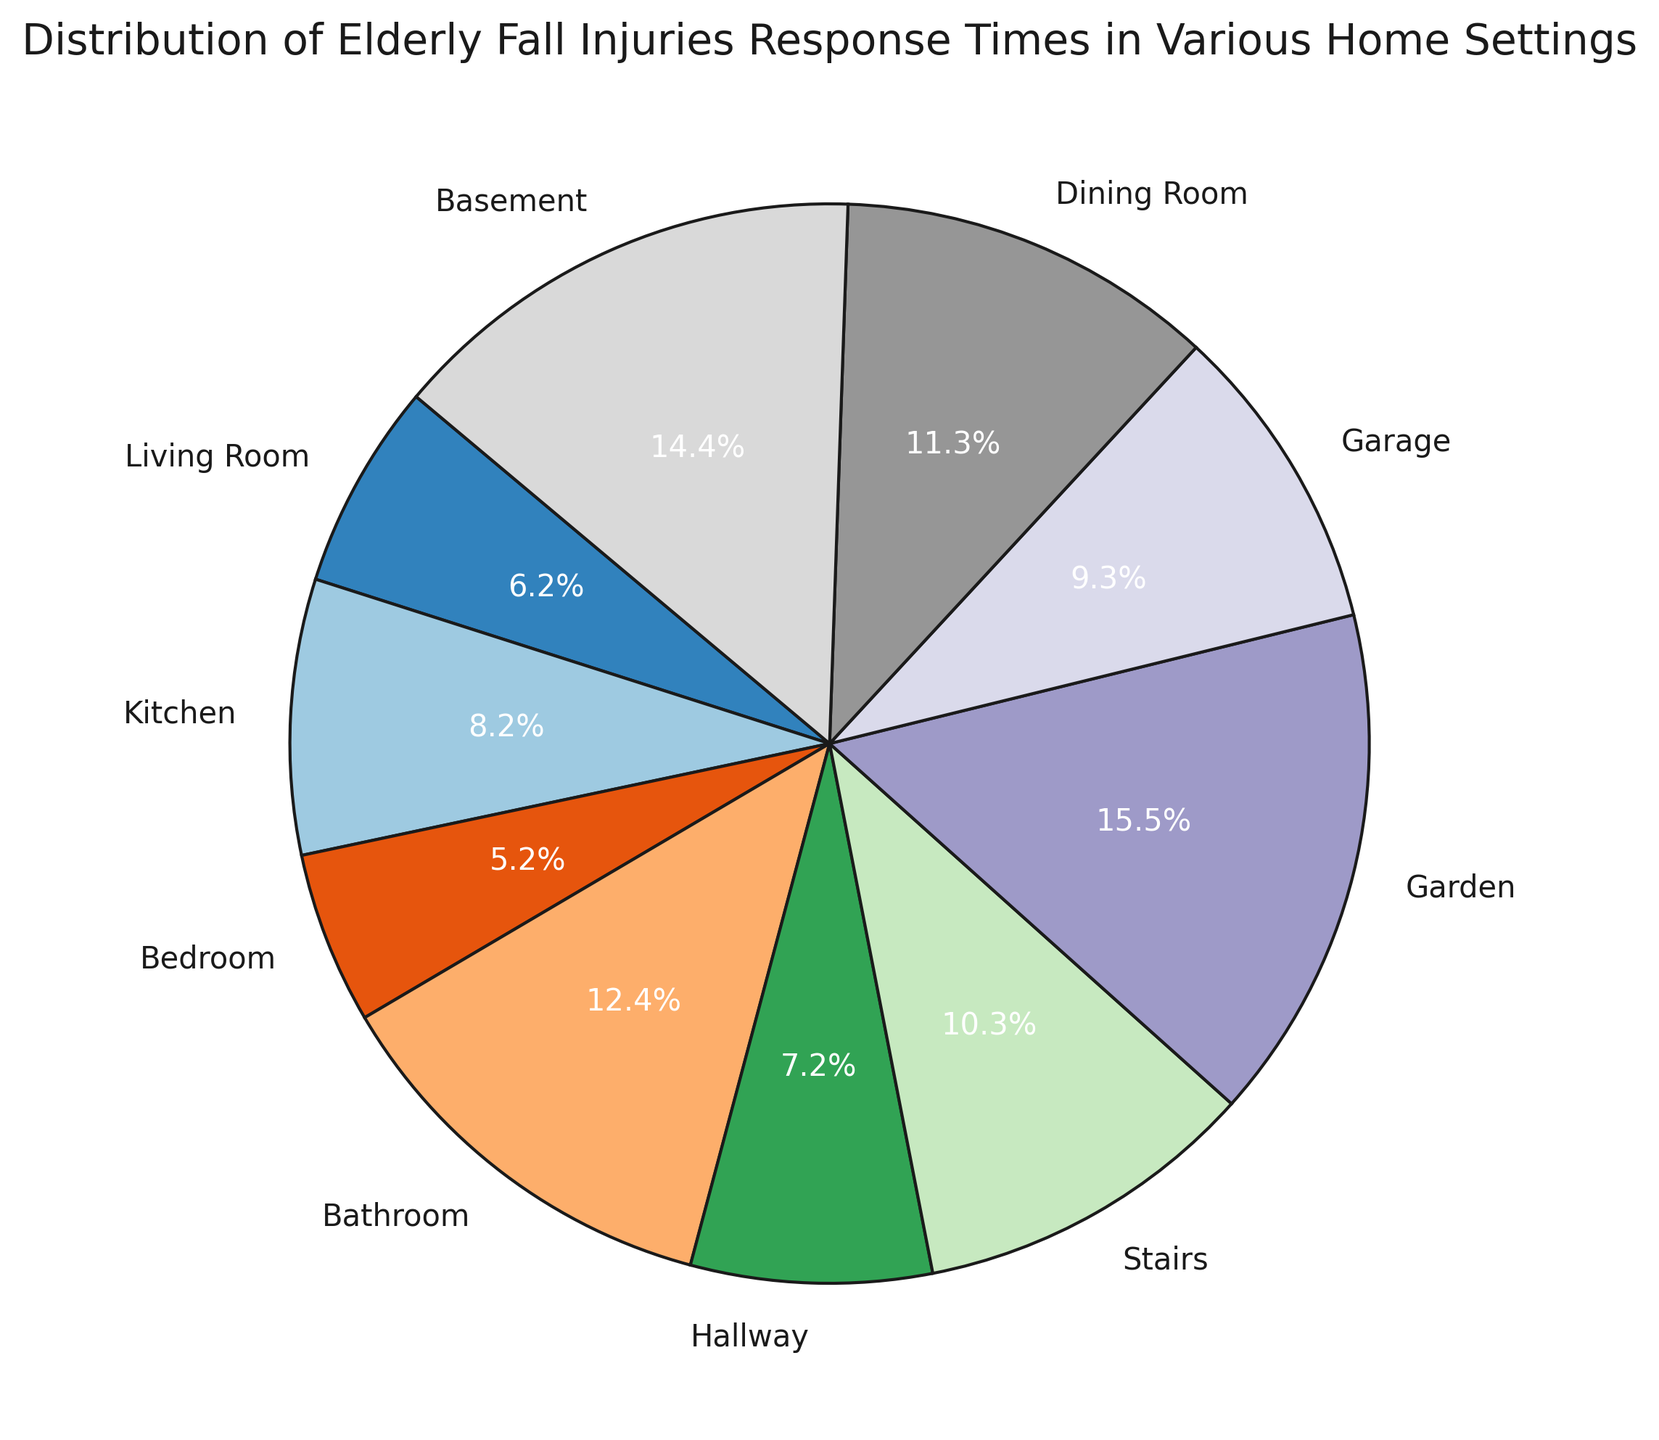What's the setting with the highest response time for elderly fall injuries? The figure shows each setting and its corresponding percentage of the total response times. The slice with the largest percentage corresponds to the setting with the highest response time. Based on the visual representation, the largest slice is for the Garden.
Answer: Garden Which setting has a shorter response time, the Kitchen or the Garage? By looking at the chart and comparing the slices labeled as Kitchen and Garage, we can see that the Kitchen slice is smaller than the Garage slice, indicating the Kitchen has a shorter response time.
Answer: Kitchen What is the combined percentage of the response times for the Bathroom and Basement settings? Locate the slices for Bathroom and Basement in the pie chart, and find their percentages. Add these percentages together to get the combined value. The Bathroom and Basement slices show 12% and 14% respectively, so 12% + 14% = 26%.
Answer: 26% Which settings have a response time greater than 10 minutes? Inspect each labeled slice and its percentage. The settings with response times represented by larger slices are: Garden (15 minutes), Basement (14 minutes), Dining Room (11 minutes), and Bathroom (12 minutes).
Answer: Garden, Basement, Dining Room, Bathroom Are there more settings with response times less than 10 minutes or greater than 10 minutes? Count the slices corresponding to response times greater than 10 minutes (4 settings: Garden, Basement, Dining Room, Bathroom) and those less than 10 minutes (6 settings: Living Room, Kitchen, Bedroom, Hallway, Stairs, Garage). There are more settings with response times less than 10 minutes.
Answer: Less than 10 minutes What is the average response time for the settings with response times less than 10 minutes? Identify and list the response times for settings less than 10 minutes: Living Room (6 minutes), Kitchen (8 minutes), Bedroom (5 minutes), Hallway (7 minutes), Stairs (10 minutes), Garage (9 minutes). Calculate the sum: 6 + 8 + 5 + 7 + 10 + 9 = 45, then divide by the number of settings (6). The average is 45 / 6 = 7.5 minutes.
Answer: 7.5 minutes What is the difference in response time between the Bedroom and Dining Room? Find the response times for Bedroom (5 minutes) and Dining Room (11 minutes). Calculate the difference: 11 - 5 = 6 minutes.
Answer: 6 minutes Which setting has the smallest slice in the pie chart, and what does it represent? The smallest slice in the pie chart visually is the Bedroom, with the least response time represented.
Answer: Bedroom, 5 minutes 